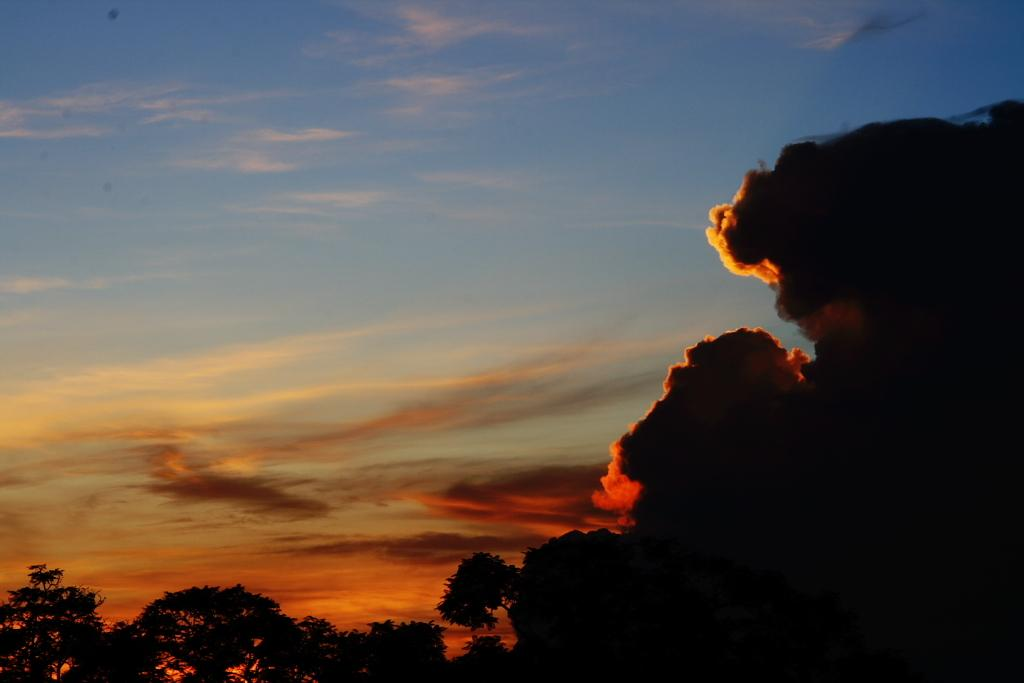What type of vegetation can be seen in the image? There are trees in the image. What can be seen in the sky in the image? There are clouds in the image. What part of the natural environment is visible in the image? The sky is visible in the image. What type of yarn is being used to create the clouds in the image? There is no yarn present in the image; the clouds are natural formations in the sky. 